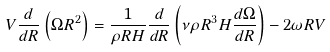Convert formula to latex. <formula><loc_0><loc_0><loc_500><loc_500>V \frac { d } { d R } \left ( \Omega R ^ { 2 } \right ) = \frac { 1 } { \rho R H } \frac { d } { d R } \left ( \nu \rho R ^ { 3 } H \frac { d \Omega } { d R } \right ) - 2 \omega R V</formula> 